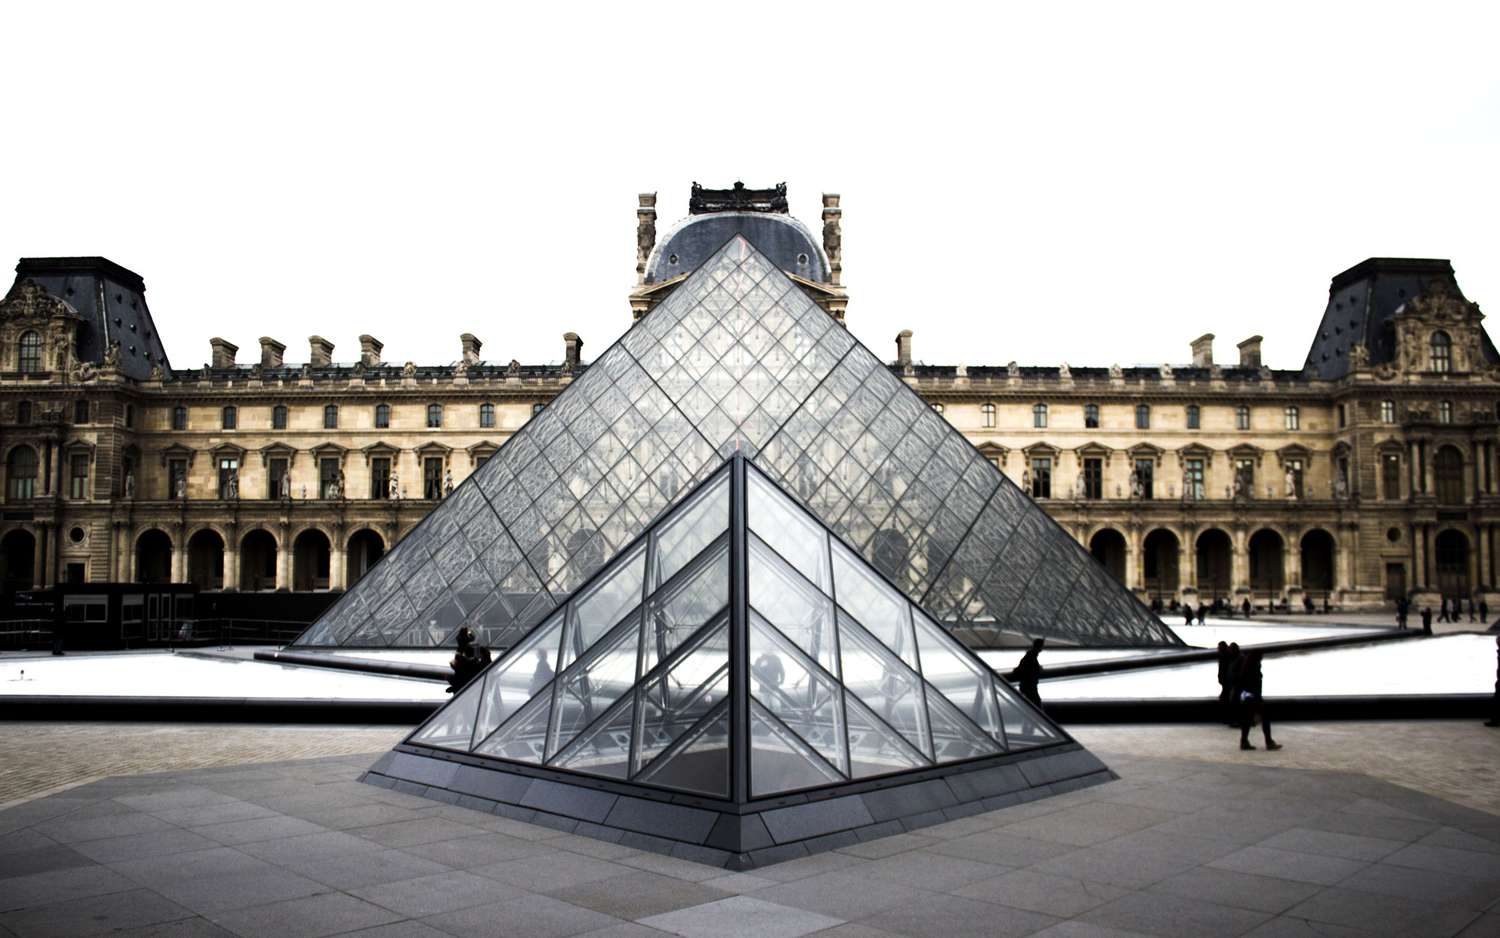What if the Louvre pyramid could change colors based on the time of day? If the Louvre pyramid could change colors based on the time of day, it would enhance the visual dynamics of the museum’s courtyard, adding an ever-changing layer to its aesthetic appeal. In the early morning, the pyramid could emit soft hues of pinks and purples, mirroring the dawn sky, and welcoming visitors with a gentle, calming atmosphere. As the day progresses, the colors could shift to vibrant blues and golds, harmonizing with the bright daylight and energizing the surroundings. 

During the afternoon, the glass structure could transition to warmer tones, like oranges and reds, reflecting the intensity of the sun and adding warmth to the historical architecture of the palace. Finally, as evening falls, the pyramid could adopt deep blues, indigos, and eventually a soft, glowing white, creating a serene and almost ethereal ambiance. This color metamorphosis would not only captivate visitors but also offer a unique way to experience the passage of time within the grounds of one of the most iconic cultural landmarks in the world. 